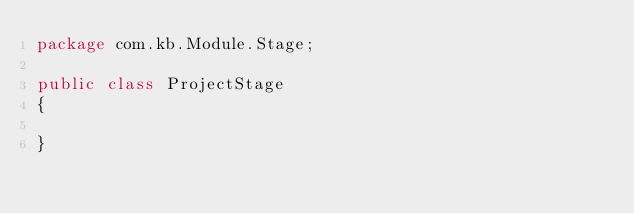<code> <loc_0><loc_0><loc_500><loc_500><_Java_>package com.kb.Module.Stage;

public class ProjectStage
{

}</code> 